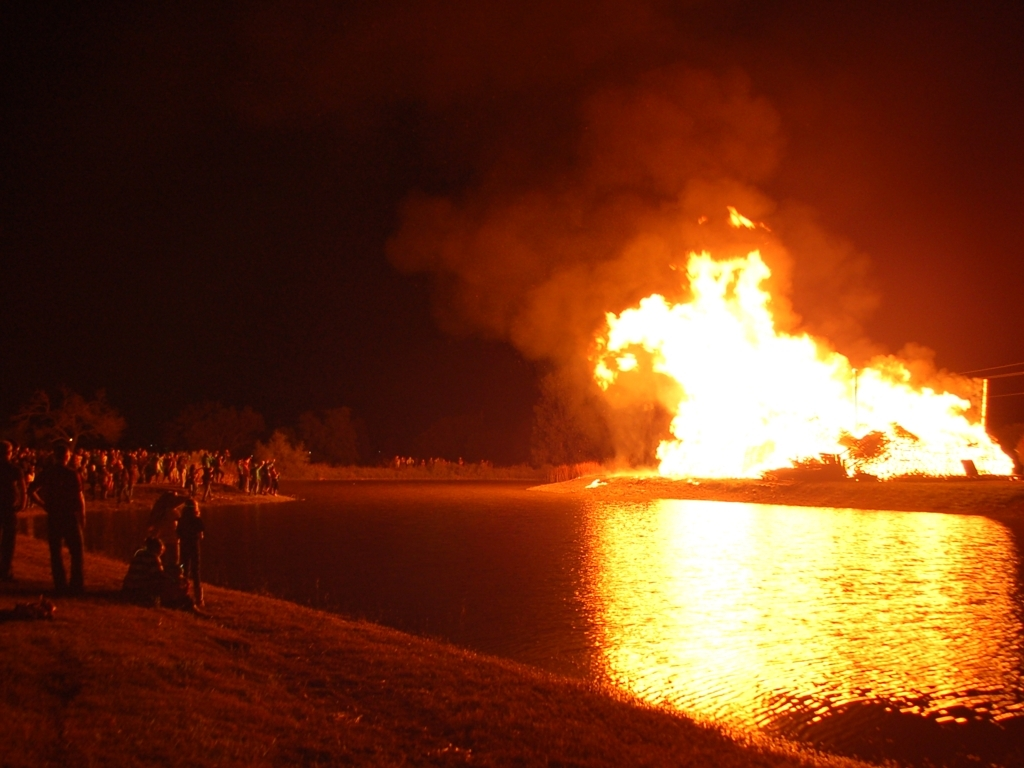Are there any quality issues with this image? While the image does capture the scene, there is noticeable graininess, and the highlights from the fire are somewhat overexposed, losing detail in the brightest areas. Moreover, the focus and sharpness could be improved to enhance the overall clarity of the scene. 